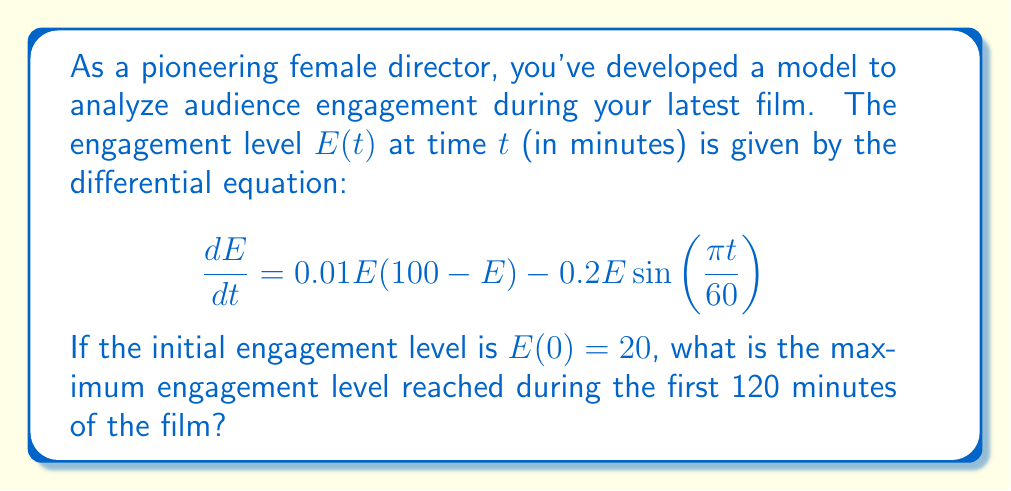Give your solution to this math problem. To solve this problem, we need to analyze the nonlinear differential equation:

1) First, observe that this is a logistic growth model with a periodic forcing term:
   - $0.01E(100 - E)$ represents logistic growth with a carrying capacity of 100
   - $-0.2E\sin(\frac{\pi t}{60})$ is a periodic forcing term with a 2-hour period

2) Due to the nonlinearity and periodic forcing, this equation doesn't have a simple analytical solution. We need to use numerical methods to solve it.

3) We can use a numerical ODE solver (like Runge-Kutta method) to solve this equation from $t=0$ to $t=120$ with initial condition $E(0) = 20$.

4) After solving numerically, we can plot the solution and find the maximum value:

[asy]
import graph;
size(200,150);

real f(real t, real E) {
  return 0.01*E*(100 - E) - 0.2*E*sin(pi*t/60);
}

pair[] data = RK4(f, 20, 0, 120, 1000);

draw(graph(data), blue);
xaxis("Time (minutes)", 0, 120, Arrow);
yaxis("Engagement", 0, 100, Arrow);

pair maxPoint = (0,20);
for(int i = 0; i < data.length; ++i) {
  if (data[i].y > maxPoint.y) maxPoint = data[i];
}

dot(maxPoint, red);
label("Maximum", maxPoint, NE);
[/asy]

5) From the numerical solution, we find that the maximum engagement level is approximately 81.2, occurring around t = 67 minutes.
Answer: 81.2 